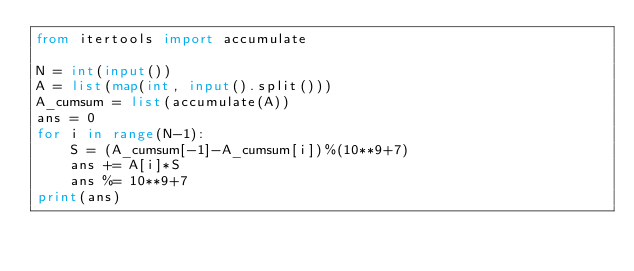<code> <loc_0><loc_0><loc_500><loc_500><_Python_>from itertools import accumulate

N = int(input())
A = list(map(int, input().split()))
A_cumsum = list(accumulate(A))
ans = 0
for i in range(N-1):
    S = (A_cumsum[-1]-A_cumsum[i])%(10**9+7)
    ans += A[i]*S
    ans %= 10**9+7
print(ans)</code> 